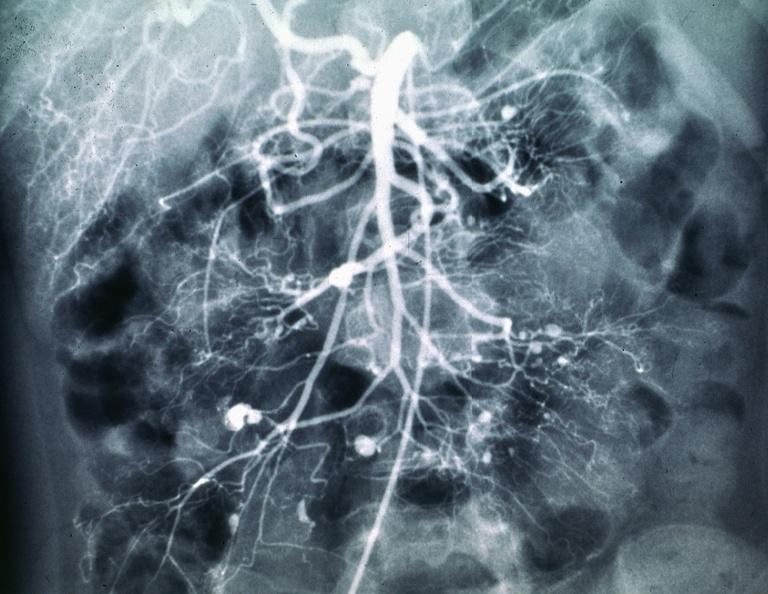s abdomen present?
Answer the question using a single word or phrase. Yes 